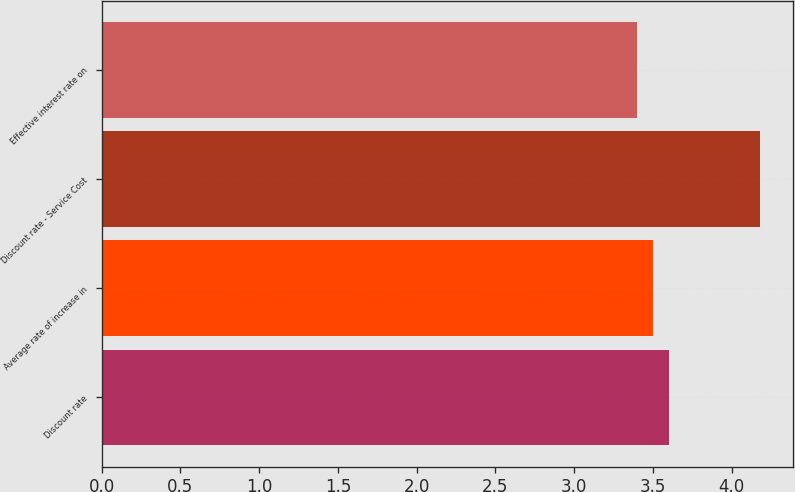<chart> <loc_0><loc_0><loc_500><loc_500><bar_chart><fcel>Discount rate<fcel>Average rate of increase in<fcel>Discount rate - Service Cost<fcel>Effective interest rate on<nl><fcel>3.6<fcel>3.5<fcel>4.18<fcel>3.4<nl></chart> 